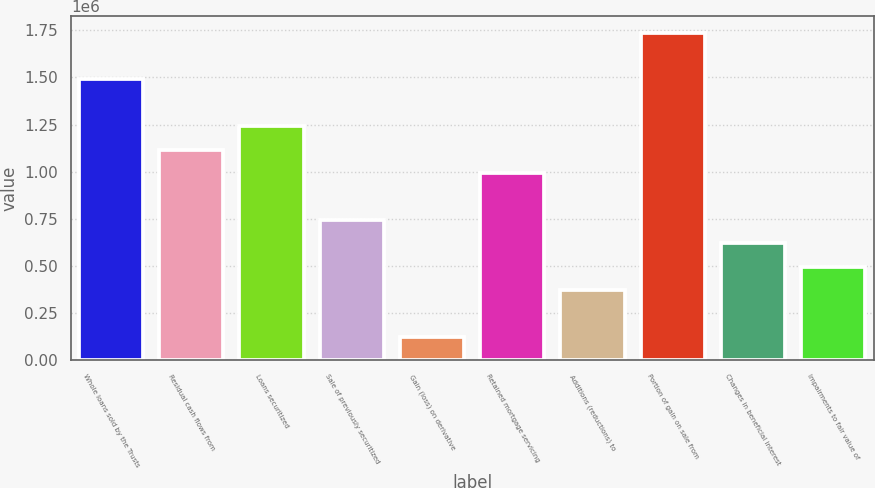<chart> <loc_0><loc_0><loc_500><loc_500><bar_chart><fcel>Whole loans sold by the Trusts<fcel>Residual cash flows from<fcel>Loans securitized<fcel>Sale of previously securitized<fcel>Gain (loss) on derivative<fcel>Retained mortgage servicing<fcel>Additions (reductions) to<fcel>Portion of gain on sale from<fcel>Changes in beneficial interest<fcel>Impairments to fair value of<nl><fcel>1.48923e+06<fcel>1.11694e+06<fcel>1.24104e+06<fcel>744660<fcel>124187<fcel>992850<fcel>372376<fcel>1.73742e+06<fcel>620566<fcel>496471<nl></chart> 